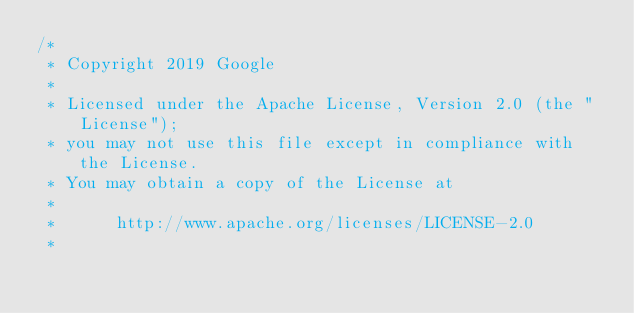<code> <loc_0><loc_0><loc_500><loc_500><_C_>/*
 * Copyright 2019 Google
 *
 * Licensed under the Apache License, Version 2.0 (the "License");
 * you may not use this file except in compliance with the License.
 * You may obtain a copy of the License at
 *
 *      http://www.apache.org/licenses/LICENSE-2.0
 *</code> 